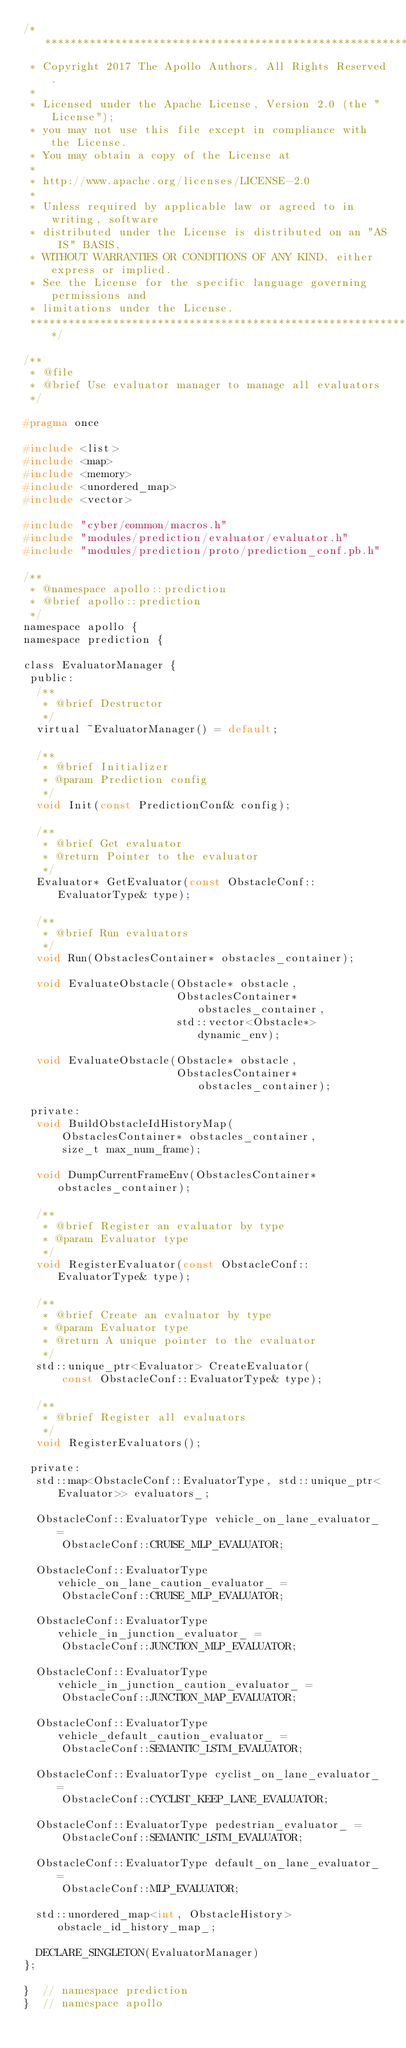<code> <loc_0><loc_0><loc_500><loc_500><_C_>/******************************************************************************
 * Copyright 2017 The Apollo Authors. All Rights Reserved.
 *
 * Licensed under the Apache License, Version 2.0 (the "License");
 * you may not use this file except in compliance with the License.
 * You may obtain a copy of the License at
 *
 * http://www.apache.org/licenses/LICENSE-2.0
 *
 * Unless required by applicable law or agreed to in writing, software
 * distributed under the License is distributed on an "AS IS" BASIS,
 * WITHOUT WARRANTIES OR CONDITIONS OF ANY KIND, either express or implied.
 * See the License for the specific language governing permissions and
 * limitations under the License.
 *****************************************************************************/

/**
 * @file
 * @brief Use evaluator manager to manage all evaluators
 */

#pragma once

#include <list>
#include <map>
#include <memory>
#include <unordered_map>
#include <vector>

#include "cyber/common/macros.h"
#include "modules/prediction/evaluator/evaluator.h"
#include "modules/prediction/proto/prediction_conf.pb.h"

/**
 * @namespace apollo::prediction
 * @brief apollo::prediction
 */
namespace apollo {
namespace prediction {

class EvaluatorManager {
 public:
  /**
   * @brief Destructor
   */
  virtual ~EvaluatorManager() = default;

  /**
   * @brief Initializer
   * @param Prediction config
   */
  void Init(const PredictionConf& config);

  /**
   * @brief Get evaluator
   * @return Pointer to the evaluator
   */
  Evaluator* GetEvaluator(const ObstacleConf::EvaluatorType& type);

  /**
   * @brief Run evaluators
   */
  void Run(ObstaclesContainer* obstacles_container);

  void EvaluateObstacle(Obstacle* obstacle,
                        ObstaclesContainer* obstacles_container,
                        std::vector<Obstacle*> dynamic_env);

  void EvaluateObstacle(Obstacle* obstacle,
                        ObstaclesContainer* obstacles_container);

 private:
  void BuildObstacleIdHistoryMap(
      ObstaclesContainer* obstacles_container,
      size_t max_num_frame);

  void DumpCurrentFrameEnv(ObstaclesContainer* obstacles_container);

  /**
   * @brief Register an evaluator by type
   * @param Evaluator type
   */
  void RegisterEvaluator(const ObstacleConf::EvaluatorType& type);

  /**
   * @brief Create an evaluator by type
   * @param Evaluator type
   * @return A unique pointer to the evaluator
   */
  std::unique_ptr<Evaluator> CreateEvaluator(
      const ObstacleConf::EvaluatorType& type);

  /**
   * @brief Register all evaluators
   */
  void RegisterEvaluators();

 private:
  std::map<ObstacleConf::EvaluatorType, std::unique_ptr<Evaluator>> evaluators_;

  ObstacleConf::EvaluatorType vehicle_on_lane_evaluator_ =
      ObstacleConf::CRUISE_MLP_EVALUATOR;

  ObstacleConf::EvaluatorType vehicle_on_lane_caution_evaluator_ =
      ObstacleConf::CRUISE_MLP_EVALUATOR;

  ObstacleConf::EvaluatorType vehicle_in_junction_evaluator_ =
      ObstacleConf::JUNCTION_MLP_EVALUATOR;

  ObstacleConf::EvaluatorType vehicle_in_junction_caution_evaluator_ =
      ObstacleConf::JUNCTION_MAP_EVALUATOR;

  ObstacleConf::EvaluatorType vehicle_default_caution_evaluator_ =
      ObstacleConf::SEMANTIC_LSTM_EVALUATOR;

  ObstacleConf::EvaluatorType cyclist_on_lane_evaluator_ =
      ObstacleConf::CYCLIST_KEEP_LANE_EVALUATOR;

  ObstacleConf::EvaluatorType pedestrian_evaluator_ =
      ObstacleConf::SEMANTIC_LSTM_EVALUATOR;

  ObstacleConf::EvaluatorType default_on_lane_evaluator_ =
      ObstacleConf::MLP_EVALUATOR;

  std::unordered_map<int, ObstacleHistory> obstacle_id_history_map_;

  DECLARE_SINGLETON(EvaluatorManager)
};

}  // namespace prediction
}  // namespace apollo
</code> 